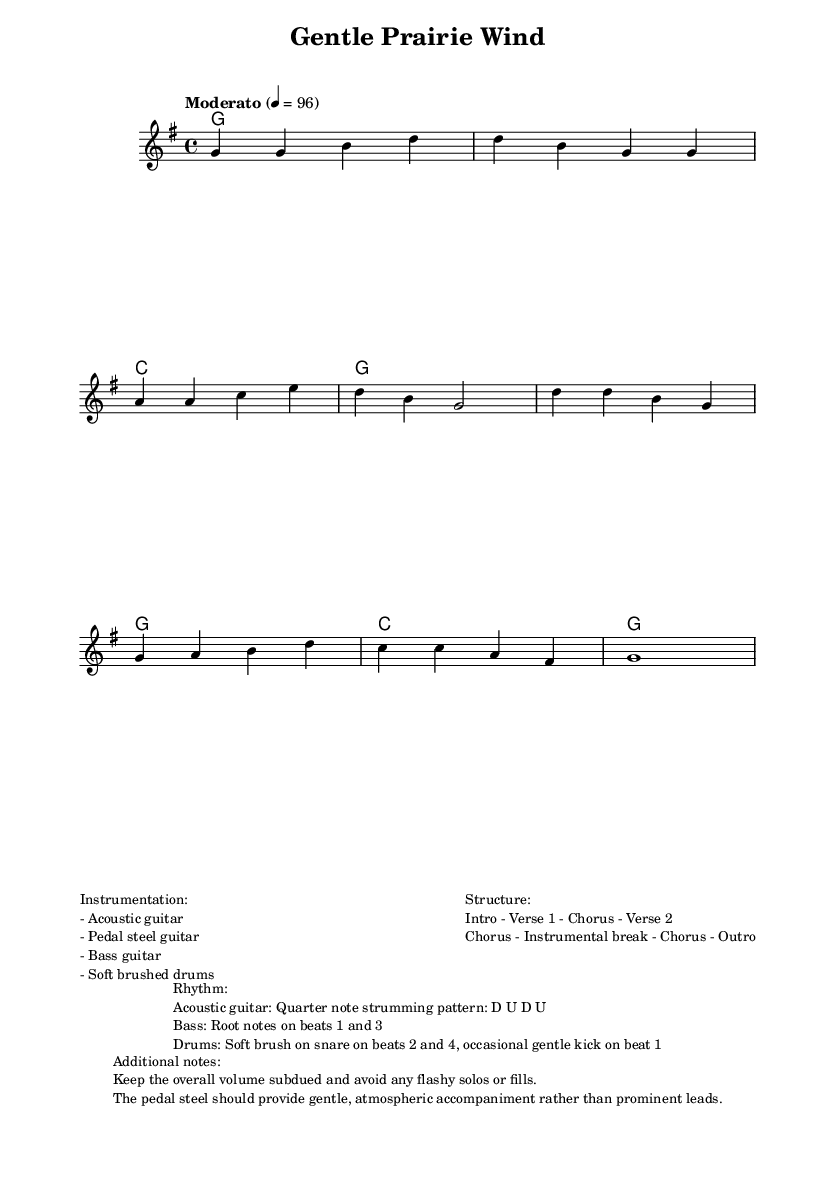What is the key signature of this music? The key signature is G major, which contains one sharp (F#) in the scale. It is typically indicated at the beginning of the staff.
Answer: G major What is the time signature of this piece? The time signature is 4/4, which means there are four beats in each measure and the quarter note gets one beat. This is noted at the beginning of the staff.
Answer: 4/4 What is the tempo marking for this piece? The tempo marking is "Moderato," which indicates a moderate speed for the piece and often is around 96 beats per minute. This can be found in the tempo indication in the score.
Answer: Moderato What instruments are used in this composition? The piece features acoustic guitar, pedal steel guitar, bass guitar, and soft brushed drums, indicated in the additional notes section of the markup.
Answer: Acoustic guitar, pedal steel guitar, bass guitar, soft brushed drums What is the structure of the composition? The structure includes an Intro, followed by Verse 1, Chorus, Verse 2, another Chorus, an Instrumental break, another Chorus, and concludes with an Outro. This is summarized in the markup section about structure.
Answer: Intro - Verse 1 - Chorus - Verse 2 - Chorus - Instrumental break - Chorus - Outro What strumming pattern is used for the acoustic guitar? The acoustic guitar uses a quarter note strumming pattern of Down-Up-Down-Up, which is described in the rhythm notes provided.
Answer: D U D U How should the pedal steel guitar be played in this piece? The pedal steel guitar should provide gentle, atmospheric accompaniment without prominent leads, as noted in the additional notes section.
Answer: Gentle, atmospheric accompaniment 